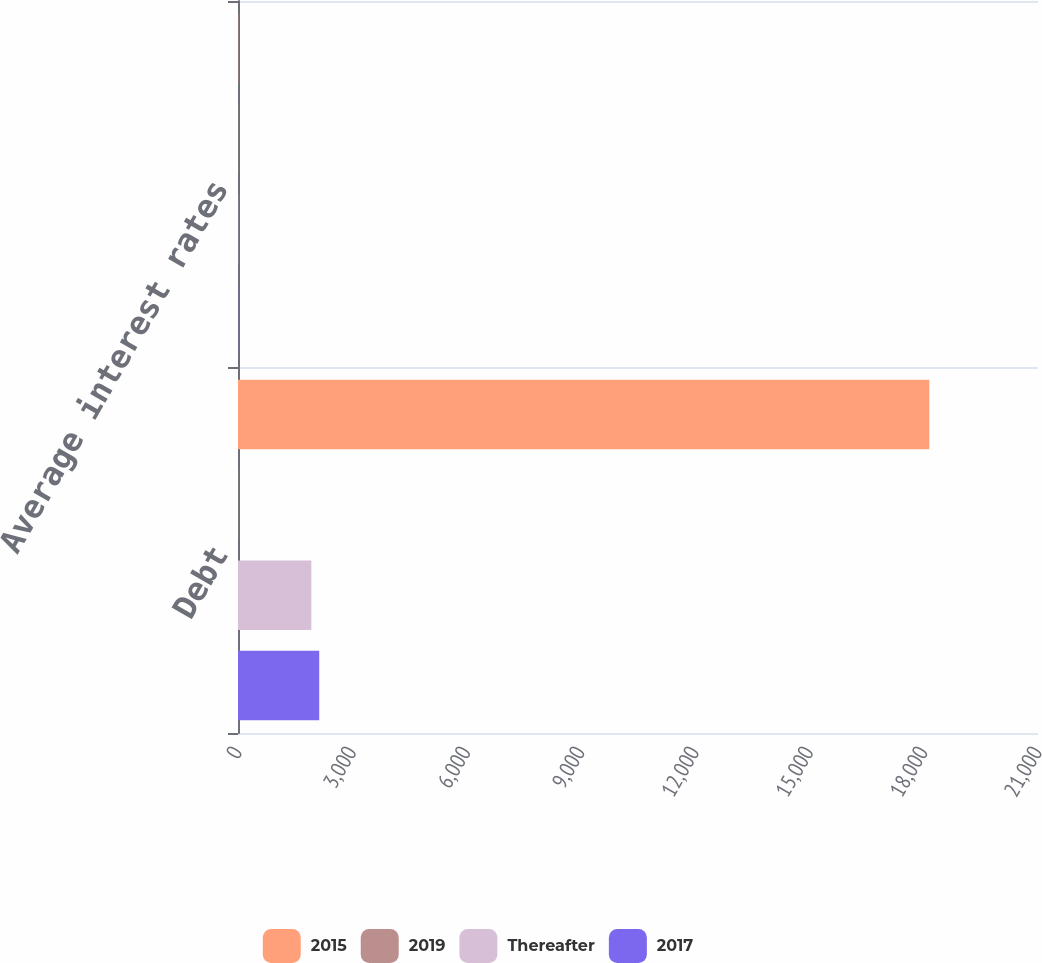<chart> <loc_0><loc_0><loc_500><loc_500><stacked_bar_chart><ecel><fcel>Debt<fcel>Average interest rates<nl><fcel>2015<fcel>18146<fcel>5.5<nl><fcel>2019<fcel>5.5<fcel>5.5<nl><fcel>Thereafter<fcel>1925<fcel>4.4<nl><fcel>2017<fcel>2132<fcel>4.4<nl></chart> 